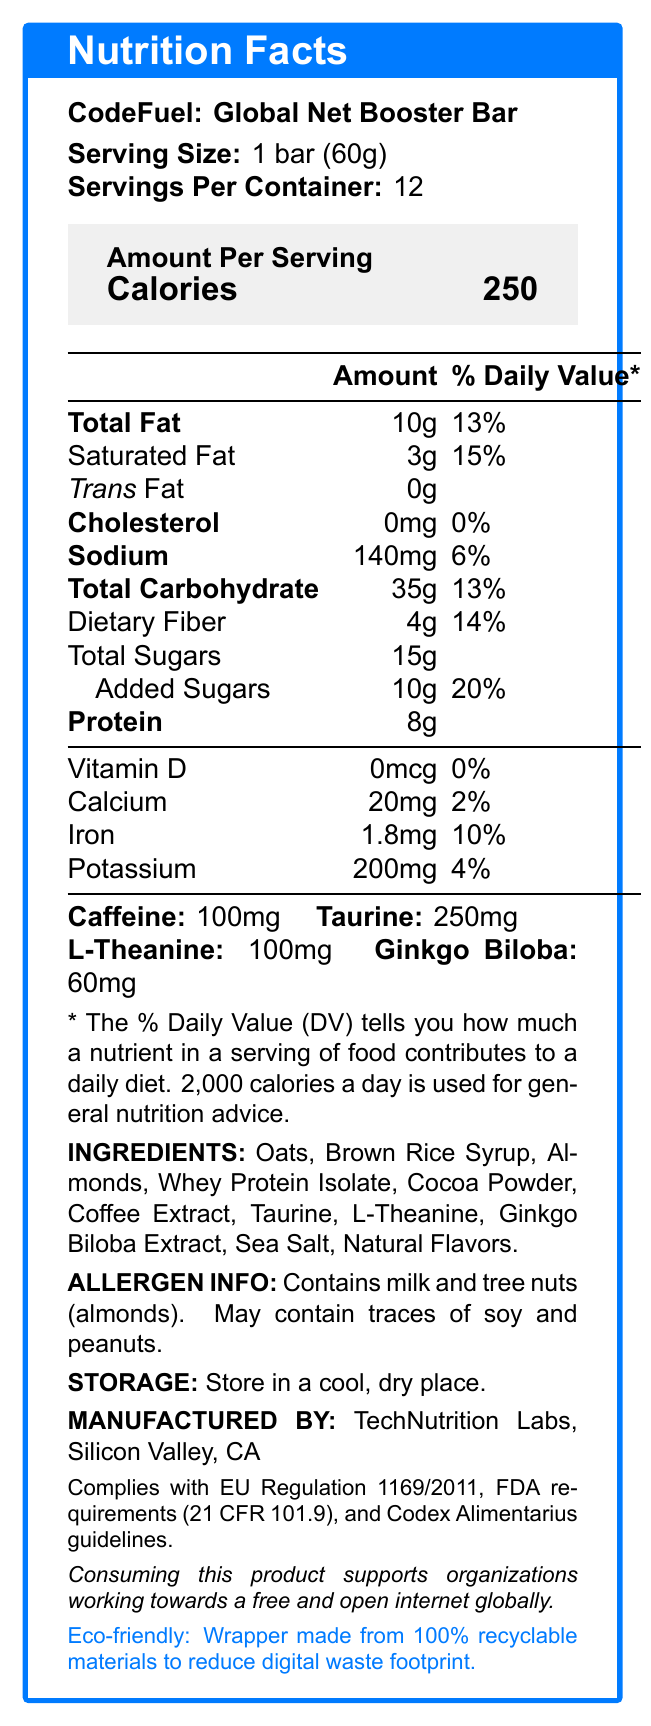What is the serving size of the CodeFuel: Global Net Booster Bar? The document clearly lists the serving size as 1 bar (60g).
Answer: 1 bar (60g) How many servings are there per container of the CodeFuel: Global Net Booster Bar? The document states that there are 12 servings per container.
Answer: 12 How much caffeine is there in one serving of the CodeFuel: Global Net Booster Bar? The amount of caffeine per serving is listed as 100mg in the document.
Answer: 100mg What is the percentage daily value of saturated fat per serving? The document specifies that the saturated fat content per serving is 3g, which contributes to 15% of the daily value.
Answer: 15% Which ingredients might trigger allergies? The allergen information section of the document notes that the product contains milk and tree nuts (almonds) and may contain traces of soy and peanuts.
Answer: Milk and tree nuts (almonds); may contain traces of soy and peanuts. What is the calorie content in one serving of the CodeFuel: Global Net Booster Bar? The amount per serving section of the document shows that one serving has 250 calories.
Answer: 250 Which of the following nutrients is not a significant source in the CodeFuel: Global Net Booster Bar? A. Iron B. Vitamin D C. Calcium The document lists Vitamin D as 0mcg with a 0% daily value, indicating it is not a significant source.
Answer: B What percentage of the daily value does dietary fiber contribute per serving? The document specifies that dietary fiber amounts to 4g, contributing 14% of the daily value per serving.
Answer: 14% True or False: The product includes significant sources of Vitamin A and Vitamin C. The disclaimer at the end of the document states, "Not a significant source of vitamin A or C."
Answer: False How much added sugar does the CodeFuel: Global Net Booster Bar contain per serving? The document indicates that the product contains 10g of added sugars per serving.
Answer: 10g Which regulatory compliances does the product meet? Select all that apply. i. EU Regulation 1169/2011 ii. FDA requirements iii. Codex Alimentarius iv. ISO Certification The document mentions that the product complies with EU Regulation 1169/2011, FDA requirements, and Codex Alimentarius guidelines.
Answer: i, ii, iii What is the storage recommendation for the CodeFuel: Global Net Booster Bar? The storage instructions in the document recommend keeping the product in a cool, dry place.
Answer: Store in a cool, dry place. What is the total fat content per serving and its percentage of the daily value? The document states that the total fat content is 10g, which is 13% of the daily value.
Answer: 10g, 13% Summarize the main idea of the document. The document is designed to inform consumers about the nutritional content, ingredients, potential allergens, storage recommendations, regulatory compliance, and eco-friendly aspects of the CodeFuel: Global Net Booster Bar.
Answer: The document provides nutrition facts for the CodeFuel: Global Net Booster Bar, detailing its serving size, servings per container, calorie count, and nutrient composition, along with ingredient information, allergen warnings, storage instructions, manufacturing details, regulatory compliance, and a note on its eco-friendly packaging and digital rights statement. What are the specific amounts of taurine and L-theanine per serving? The document lists the amounts of taurine and L-theanine as 250mg and 100mg respectively.
Answer: Taurine: 250mg, L-Theanine: 100mg Who manufactures the CodeFuel: Global Net Booster Bar? The document states that the product is manufactured by TechNutrition Labs located in Silicon Valley, CA.
Answer: TechNutrition Labs, Silicon Valley, CA What is the iron content per serving, and how does it contribute to the daily value? The document specifies that each serving contains 1.8mg of iron, which is 10% of the daily value.
Answer: 1.8mg, 10% Does the product contain any cholesterol? The document lists the cholesterol content as 0mg with a 0% daily value, indicating no cholesterol content.
Answer: No How does consuming the CodeFuel: Global Net Booster Bar support global internet projects? The digital rights statement in the document mentions that consuming the product supports organizations advocating for a free and open internet globally.
Answer: It supports organizations working towards a free and open internet globally. Is the ethical stance of the product regarding digital waste mentioned? The document specifies that the product is packaged using 100% recyclable materials, emphasizing a reduced digital waste footprint.
Answer: Yes, the product uses eco-friendly packaging made from 100% recyclable materials to reduce digital waste footprint. How much potassium is there per serving and what percentage of the daily value does this represent? The document mentions that the potassium content per serving is 200mg, which is 4% of the daily value.
Answer: 200mg, 4% Can you determine the exact manufacturing process of the CodeFuel: Global Net Booster Bar from the document? The document does not provide detailed information about the manufacturing process of the product, only the manufacturer’s name and location.
Answer: Not enough information 